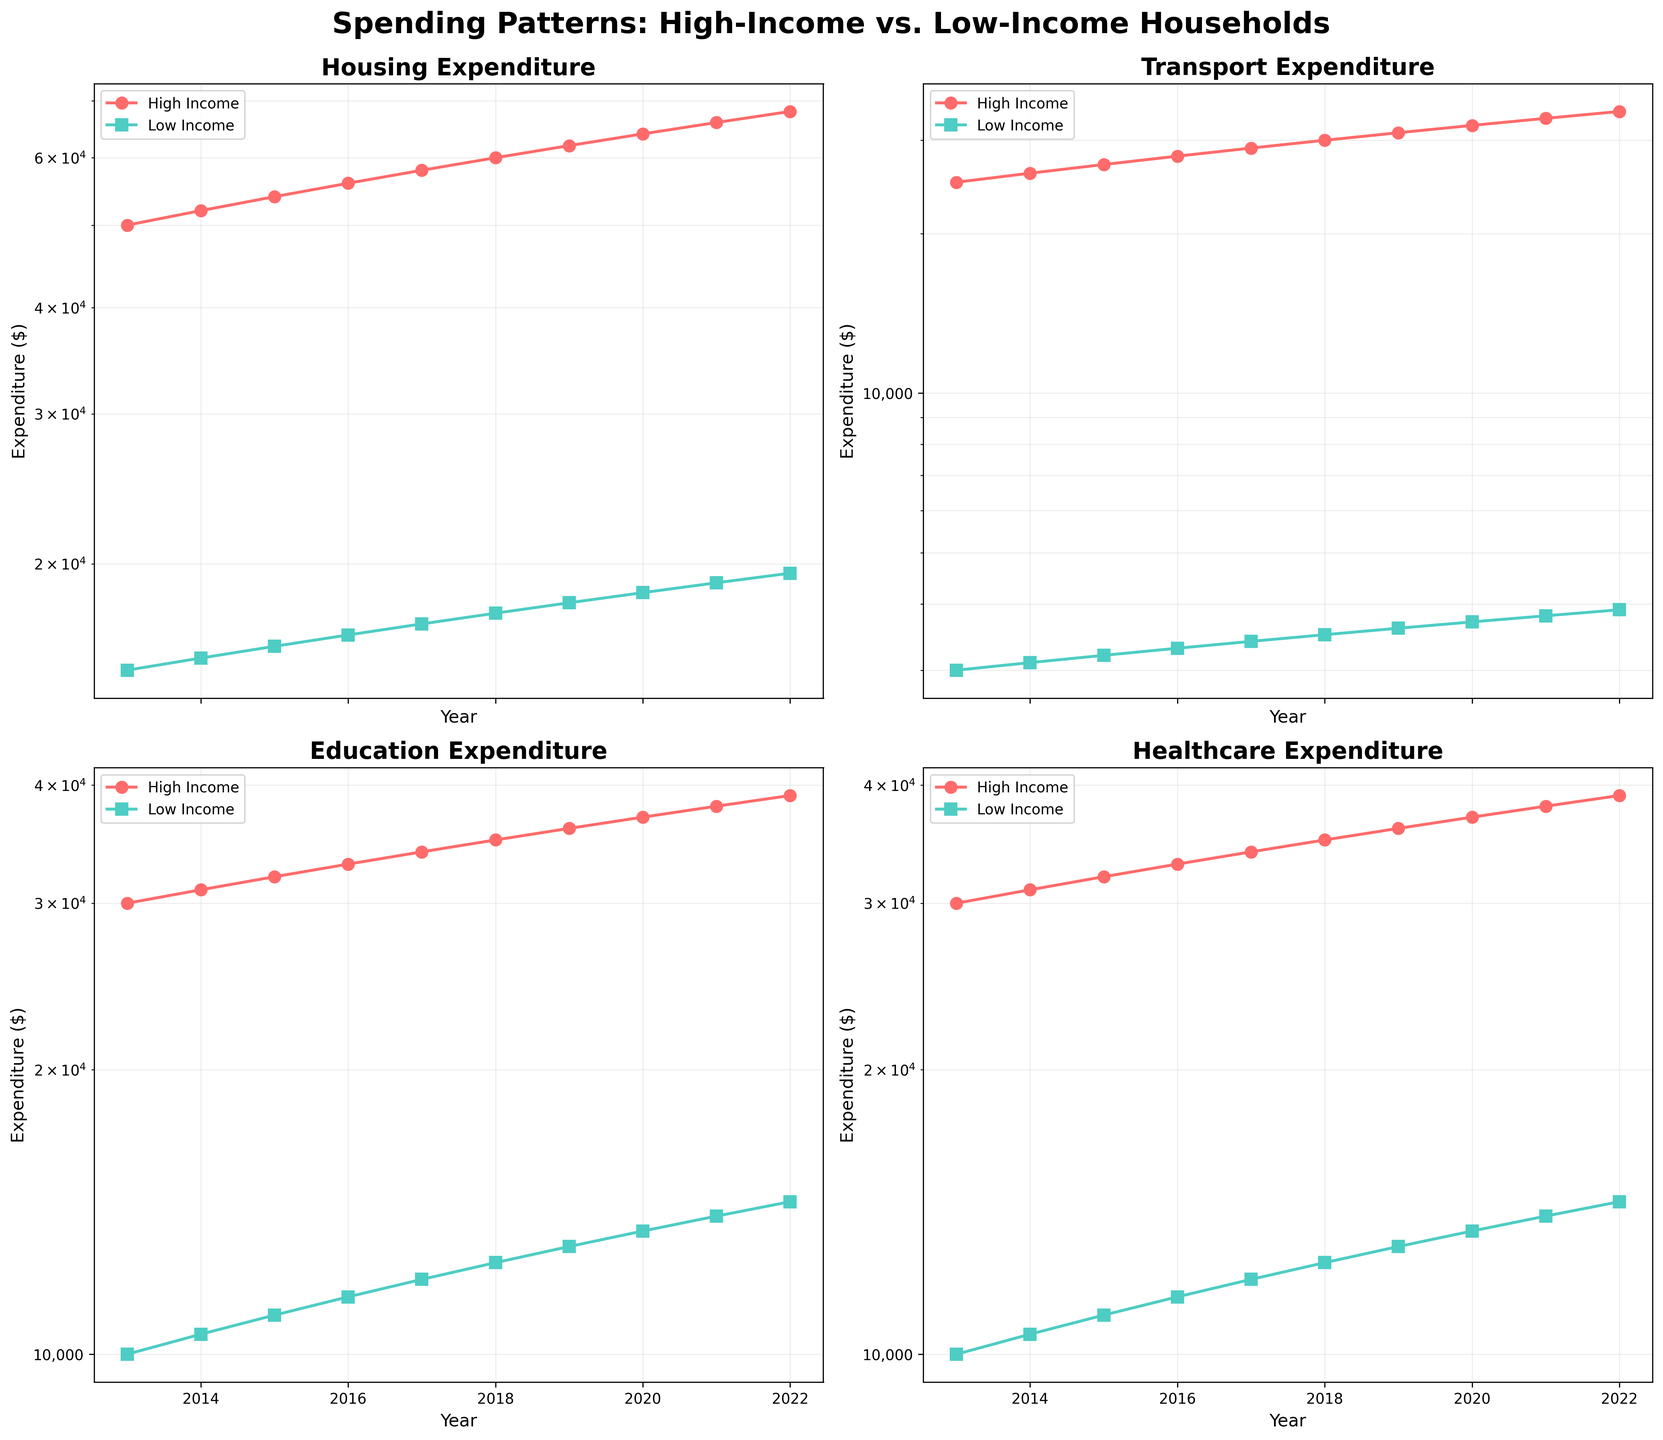What is the title of the figure? The title appears at the top of the figure. It reads 'Spending Patterns: High-Income vs. Low-Income Households'.
Answer: Spending Patterns: High-Income vs. Low-Income Households How is the color coding used to distinguish between high-income and low-income household expenditures? The figure uses different line styles and markers: high-income is represented with circles and a reddish color, while low-income is represented with squares and a turquoise color.
Answer: High-income: red circles, Low-income: turquoise squares Which category had the highest high-income expenditure in 2022? By looking at the y-axis values on the log scale, Healthcare has the highest high-income expenditure in 2022 at around $39,000.
Answer: Healthcare Which household type spent more on education in 2018 and by how much? Comparing the y-axis values for the 'Education' subplot in 2018, high-income households spent around $35,000, whereas low-income households spent around $12,500. The difference is $35,000 - $12,500 = $22,500.
Answer: High-income, by $22,500 What trend do you observe in low-income healthcare spending from 2013 to 2022? From the 'Healthcare' subplot, the line representing low-income households shows a steady and consistent increase from $3,000 in 2013 to around $14,500 in 2022.
Answer: Steady increase Between 2015 and 2016, which category saw the smallest increase in high-income expenditure? By looking at the slopes of the lines for high-income households from 2015 to 2016 across all subplots, Housing shows the smallest increase (from $54,000 to $56,000, an increase of $2,000).
Answer: Housing In 2017, how much more did high-income households spend on transport compared to low-income households? Referring to the 'Transport' subplot for 2017, high-income households spent about $29,000, while low-income households spent around $3,400. The difference is $29,000 - $3,400 = $25,600.
Answer: $25,600 Which category exhibits the greatest disparity between high-income and low-income spending as of 2022? By comparing the final data points in the year 2022 across all subplots, Education shows the greatest disparity, with high-income households at around $39,000 and low-income at around $14,500, a difference of $24,500.
Answer: Education What has been the overall trend in the transport expenditure for both income groups from 2013 to 2022? Both high-income and low-income transport expenditures show a generally upward trend over the years. High-income increases from $25,000 to $34,000 and low-income from $3,000 to $7,900.
Answer: Upward trend How does the expenditure on housing in 2015 compare between high-income and low-income households? Looking at the y-axis in the 'Housing' subplot for 2015, high-income households spent about $54,000, while low-income households spent about $16,000.
Answer: High-income: $54,000, Low-income: $16,000 